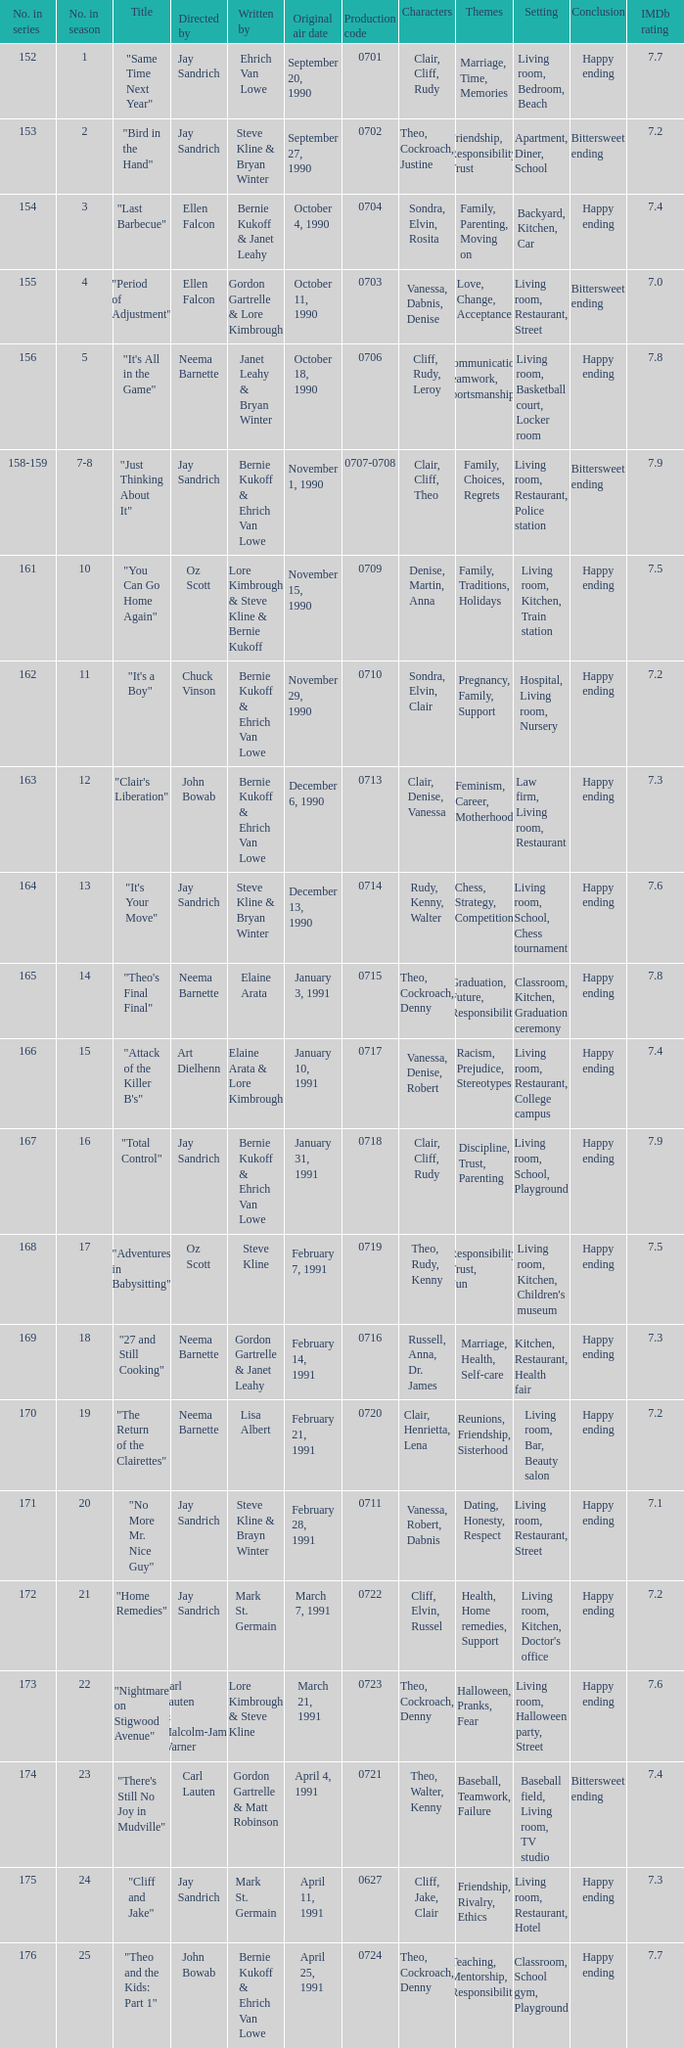The episode directed by art dielhenn was what number in the series?  166.0. 